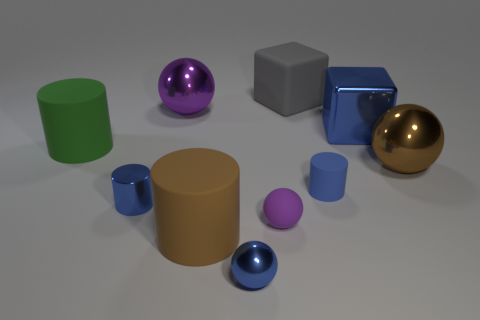What material is the large brown thing that is the same shape as the tiny blue rubber thing?
Offer a terse response. Rubber. Is the number of purple things to the left of the brown matte cylinder greater than the number of metallic cylinders that are behind the big matte cube?
Offer a very short reply. Yes. The gray object that is made of the same material as the large green cylinder is what shape?
Offer a terse response. Cube. How many other objects are there of the same shape as the small blue rubber thing?
Provide a short and direct response. 3. What shape is the big brown object to the left of the small blue rubber object?
Your response must be concise. Cylinder. The metallic cube has what color?
Offer a very short reply. Blue. How many other things are there of the same size as the rubber sphere?
Ensure brevity in your answer.  3. What material is the cylinder right of the big thing behind the large purple metallic ball made of?
Offer a terse response. Rubber. There is a blue sphere; is its size the same as the matte cylinder to the right of the gray rubber object?
Offer a terse response. Yes. Is there another large cylinder of the same color as the metal cylinder?
Your response must be concise. No. 